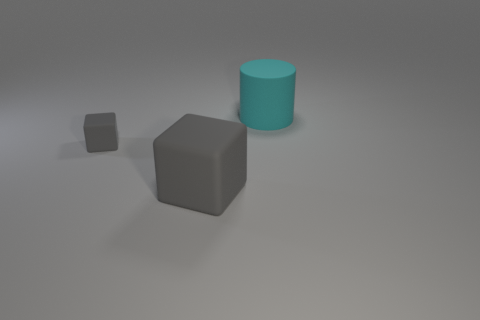There is another thing that is the same size as the cyan object; what is its color?
Offer a terse response. Gray. What number of things are either gray rubber objects to the right of the small gray rubber thing or large gray matte objects?
Offer a very short reply. 1. There is a thing that is both on the right side of the small matte object and in front of the big cylinder; how big is it?
Your answer should be compact. Large. The rubber thing that is the same color as the big block is what size?
Keep it short and to the point. Small. What number of other things are there of the same size as the rubber cylinder?
Provide a succinct answer. 1. The large thing in front of the rubber thing that is behind the gray matte thing that is on the left side of the big gray rubber block is what color?
Give a very brief answer. Gray. What shape is the rubber object that is both behind the big gray rubber object and on the right side of the small rubber object?
Provide a succinct answer. Cylinder. What number of other things are the same shape as the cyan thing?
Give a very brief answer. 0. There is a big thing that is behind the gray matte object that is behind the big rubber object in front of the cylinder; what shape is it?
Keep it short and to the point. Cylinder. What number of objects are either large cyan things or things to the left of the cyan cylinder?
Ensure brevity in your answer.  3. 